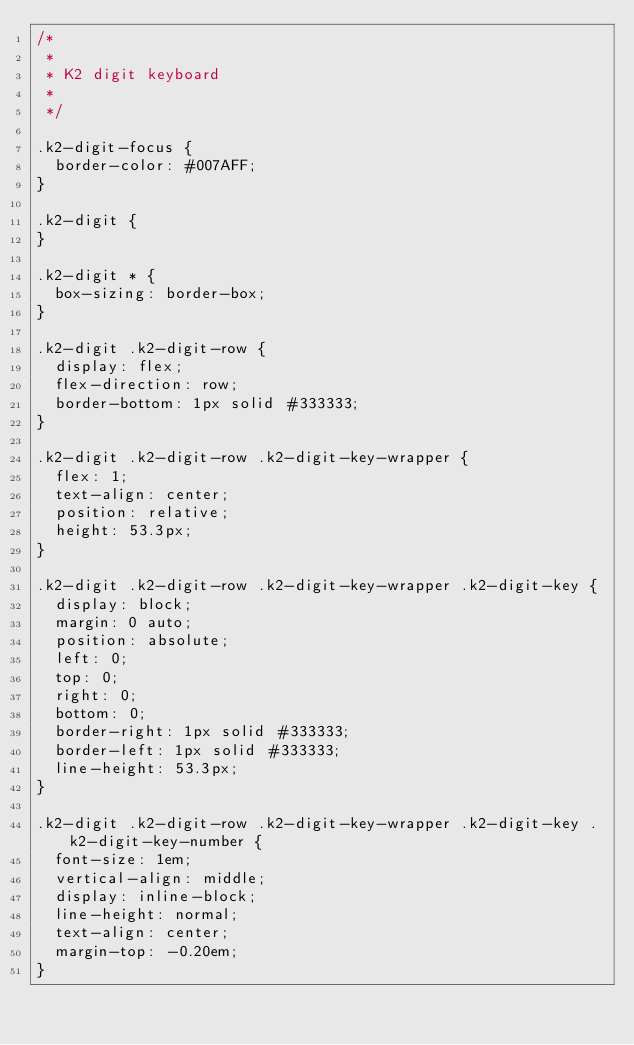Convert code to text. <code><loc_0><loc_0><loc_500><loc_500><_CSS_>/*
 *
 * K2 digit keyboard
 * 
 */

.k2-digit-focus {
	border-color: #007AFF;
}

.k2-digit {
}

.k2-digit * {
	box-sizing: border-box;
}

.k2-digit .k2-digit-row {
	display: flex;
	flex-direction: row;
	border-bottom: 1px solid #333333;
}

.k2-digit .k2-digit-row .k2-digit-key-wrapper {
	flex: 1;
	text-align: center;
	position: relative;
	height: 53.3px;
}

.k2-digit .k2-digit-row .k2-digit-key-wrapper .k2-digit-key {
	display: block;
	margin: 0 auto;
	position: absolute;
	left: 0;
	top: 0;
	right: 0;
	bottom: 0;
	border-right: 1px solid #333333;
	border-left: 1px solid #333333;
	line-height: 53.3px;
}

.k2-digit .k2-digit-row .k2-digit-key-wrapper .k2-digit-key .k2-digit-key-number {
	font-size: 1em;
	vertical-align: middle;
	display: inline-block;
	line-height: normal;
	text-align: center;
	margin-top: -0.20em;
}
</code> 